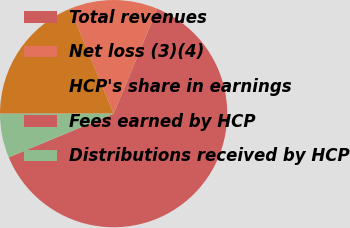<chart> <loc_0><loc_0><loc_500><loc_500><pie_chart><fcel>Total revenues<fcel>Net loss (3)(4)<fcel>HCP's share in earnings<fcel>Fees earned by HCP<fcel>Distributions received by HCP<nl><fcel>62.44%<fcel>12.51%<fcel>18.75%<fcel>0.03%<fcel>6.27%<nl></chart> 